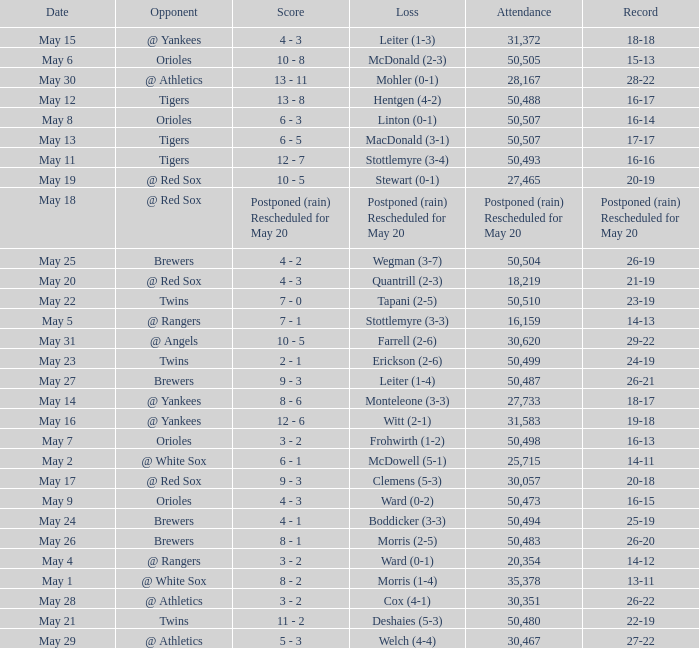What team did they lose to when they had a 28-22 record? Mohler (0-1). 